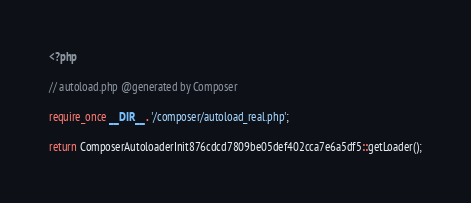<code> <loc_0><loc_0><loc_500><loc_500><_PHP_><?php

// autoload.php @generated by Composer

require_once __DIR__ . '/composer/autoload_real.php';

return ComposerAutoloaderInit876cdcd7809be05def402cca7e6a5df5::getLoader();
</code> 